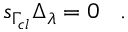Convert formula to latex. <formula><loc_0><loc_0><loc_500><loc_500>s _ { \Gamma _ { c l } } \Delta _ { \lambda } = 0 \, .</formula> 